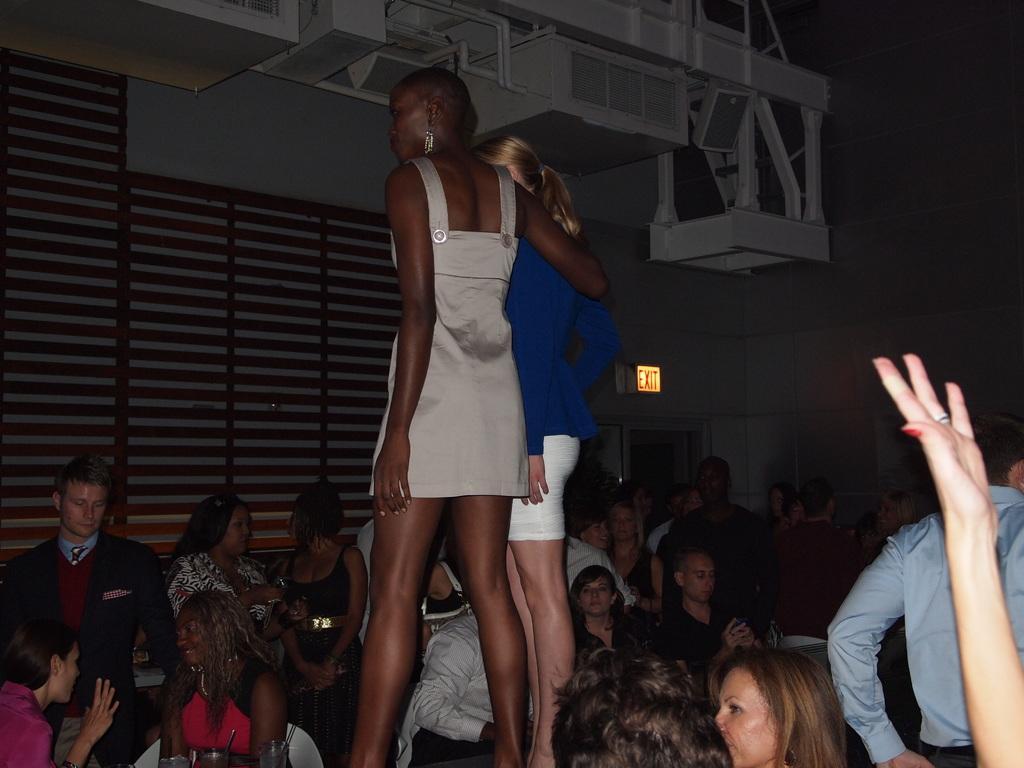Describe this image in one or two sentences. In this image we can see two ladies standing. At the bottom there are people sitting. In the background there is a wall and a door. 